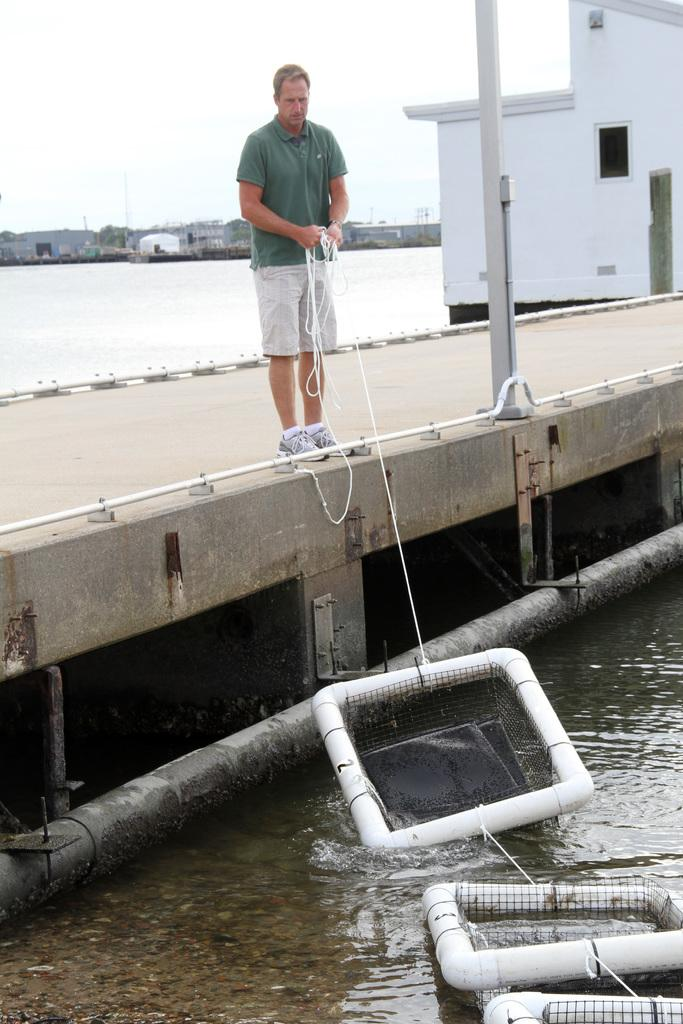Who is present in the image? There is a man in the image. Where is the man located? The man is standing on a bridge. What is the man holding in his hand? The man is holding a rope in his hand. What is the rope connected to? The rope is tied to some objects. What is the location of the objects? The objects are on the water surface. What type of education is being provided on the island in the image? There is no island present in the image, and therefore no education being provided. What type of liquid is being used to clean the objects in the image? There is no liquid present in the image, and the objects are not being cleaned. 